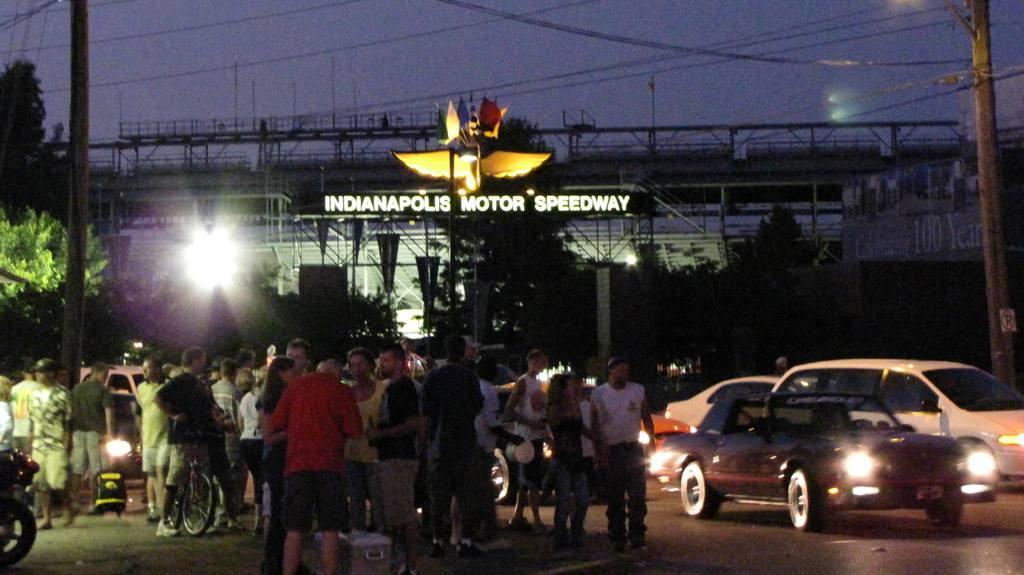In one or two sentences, can you explain what this image depicts? In this picture I can see the road in front, on which there are number of people and few cars. In the background I can see a board on which there is something written and I see few poles, wires and the sky and I can also see few trees. 